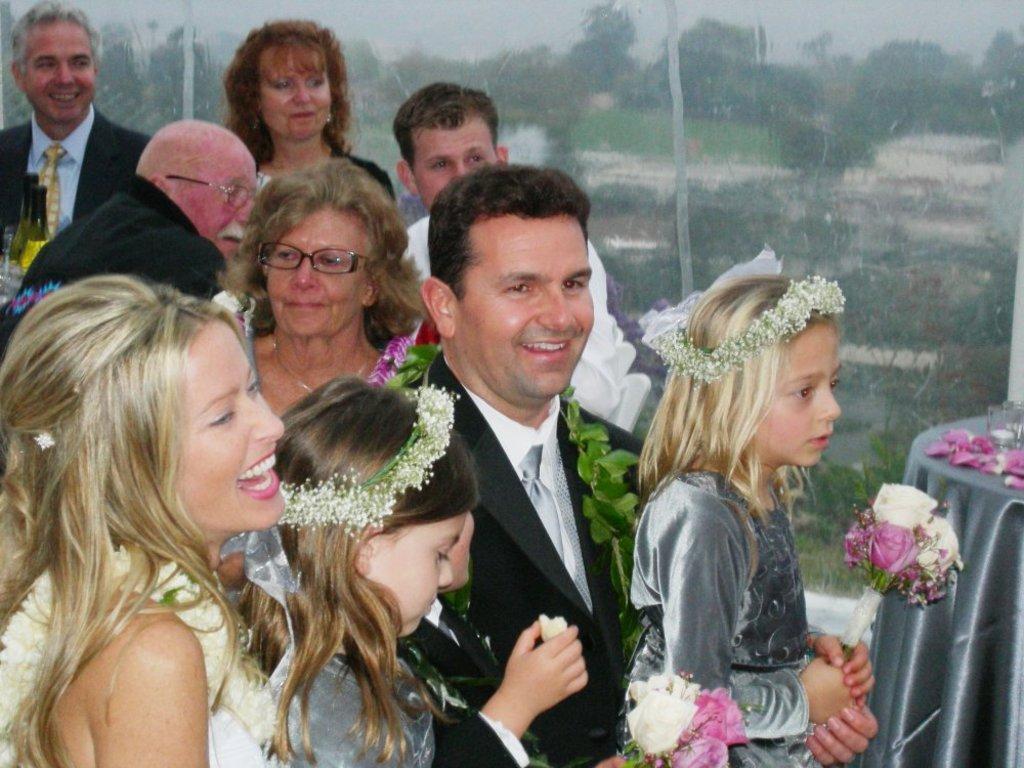In one or two sentences, can you explain what this image depicts? In this image I can see there are group of persons and some of them are smiling and I can see a table on the left side and on the table I can see cloth and glass and I can see the sky and trees visible at the top. 